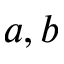<formula> <loc_0><loc_0><loc_500><loc_500>a , b</formula> 